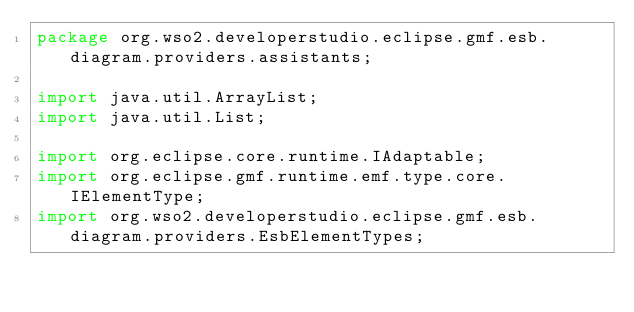Convert code to text. <code><loc_0><loc_0><loc_500><loc_500><_Java_>package org.wso2.developerstudio.eclipse.gmf.esb.diagram.providers.assistants;

import java.util.ArrayList;
import java.util.List;

import org.eclipse.core.runtime.IAdaptable;
import org.eclipse.gmf.runtime.emf.type.core.IElementType;
import org.wso2.developerstudio.eclipse.gmf.esb.diagram.providers.EsbElementTypes;</code> 